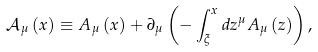<formula> <loc_0><loc_0><loc_500><loc_500>\mathcal { A } _ { \mu } \left ( x \right ) \equiv A _ { \mu } \left ( x \right ) + \partial _ { \mu } \left ( { - \int _ { \xi } ^ { x } { d z ^ { \mu } } A _ { \mu } \left ( z \right ) } \right ) ,</formula> 